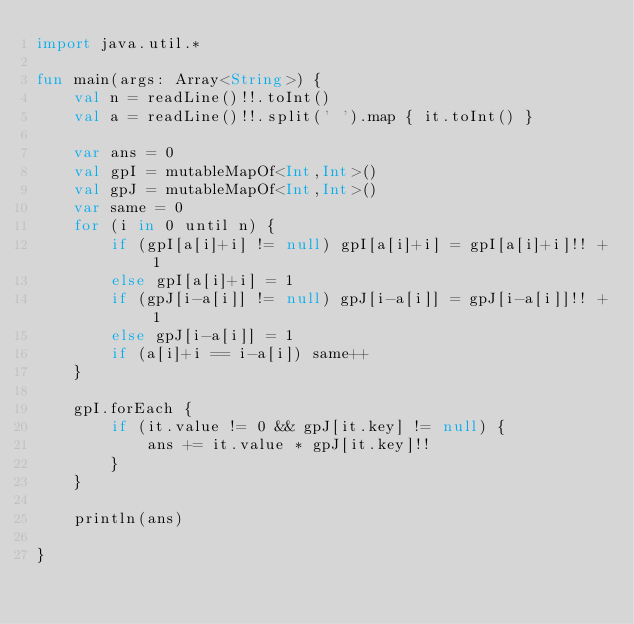Convert code to text. <code><loc_0><loc_0><loc_500><loc_500><_Kotlin_>import java.util.*

fun main(args: Array<String>) {
    val n = readLine()!!.toInt()
    val a = readLine()!!.split(' ').map { it.toInt() }

    var ans = 0
    val gpI = mutableMapOf<Int,Int>()
    val gpJ = mutableMapOf<Int,Int>()
    var same = 0
    for (i in 0 until n) {
        if (gpI[a[i]+i] != null) gpI[a[i]+i] = gpI[a[i]+i]!! + 1
        else gpI[a[i]+i] = 1
        if (gpJ[i-a[i]] != null) gpJ[i-a[i]] = gpJ[i-a[i]]!! + 1
        else gpJ[i-a[i]] = 1
        if (a[i]+i == i-a[i]) same++
    }

    gpI.forEach {
        if (it.value != 0 && gpJ[it.key] != null) {
            ans += it.value * gpJ[it.key]!!
        }
    }

    println(ans)

}

</code> 